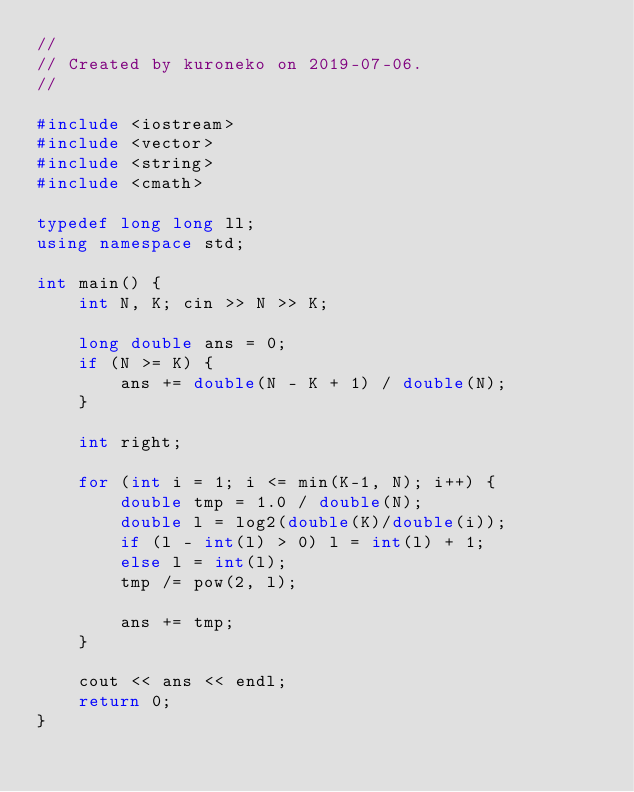<code> <loc_0><loc_0><loc_500><loc_500><_C++_>//
// Created by kuroneko on 2019-07-06.
//

#include <iostream>
#include <vector>
#include <string>
#include <cmath>

typedef long long ll;
using namespace std;

int main() {
    int N, K; cin >> N >> K;

    long double ans = 0;
    if (N >= K) {
        ans += double(N - K + 1) / double(N);
    }

    int right;

    for (int i = 1; i <= min(K-1, N); i++) {
        double tmp = 1.0 / double(N);
        double l = log2(double(K)/double(i));
        if (l - int(l) > 0) l = int(l) + 1;
        else l = int(l);
        tmp /= pow(2, l);

        ans += tmp;
    }

    cout << ans << endl;
    return 0;
}</code> 